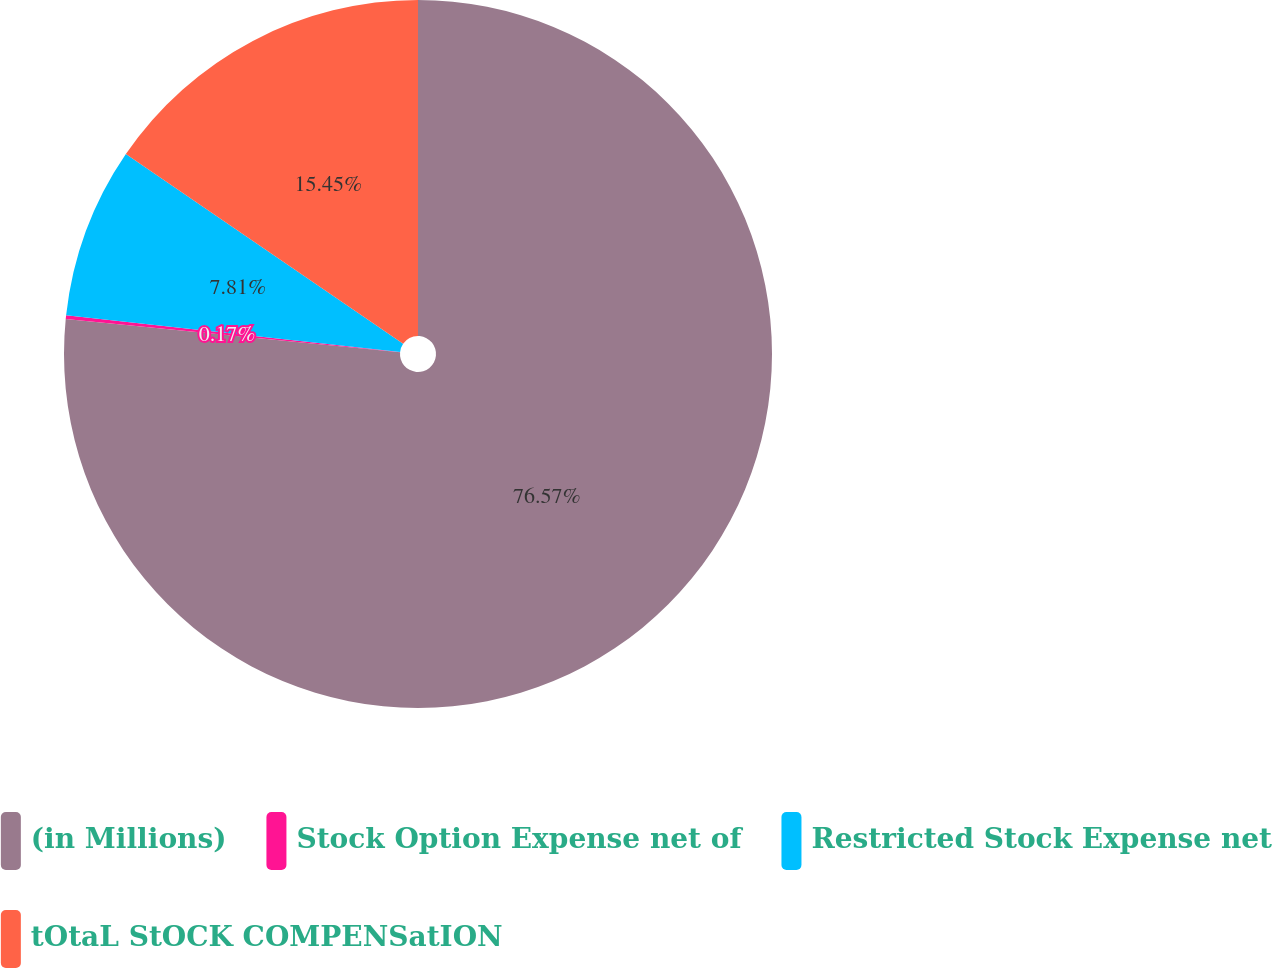<chart> <loc_0><loc_0><loc_500><loc_500><pie_chart><fcel>(in Millions)<fcel>Stock Option Expense net of<fcel>Restricted Stock Expense net<fcel>tOtaL StOCK COMPENSatION<nl><fcel>76.58%<fcel>0.17%<fcel>7.81%<fcel>15.45%<nl></chart> 